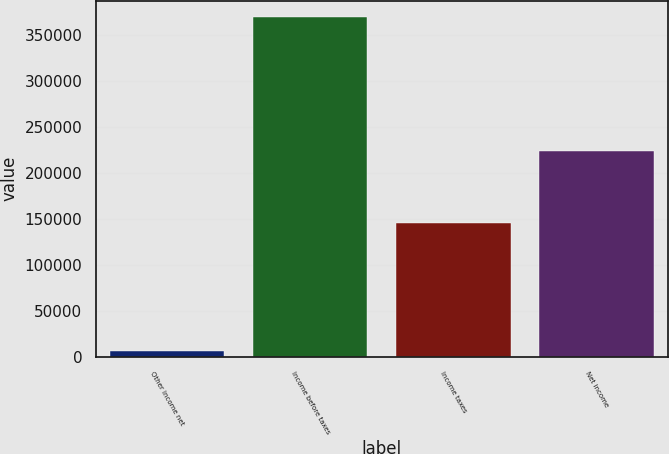Convert chart. <chart><loc_0><loc_0><loc_500><loc_500><bar_chart><fcel>Other income net<fcel>Income before taxes<fcel>Income taxes<fcel>Net income<nl><fcel>6835<fcel>369591<fcel>145381<fcel>224210<nl></chart> 